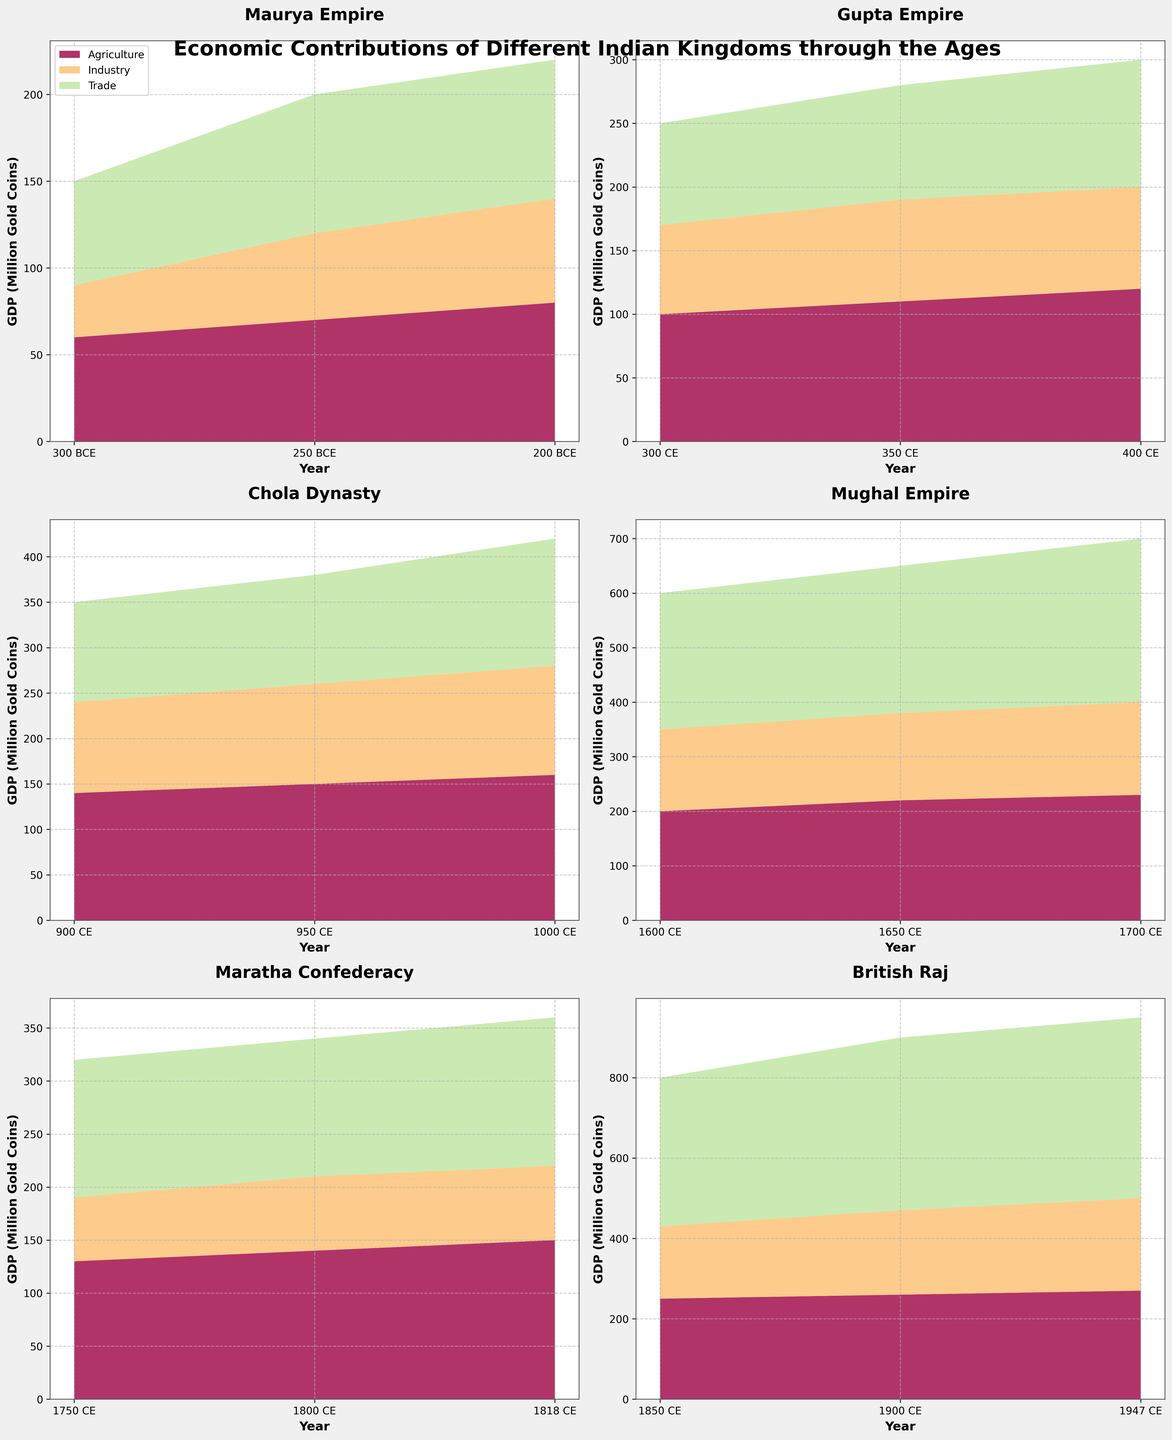Which kingdom has the highest GDP near the year 300 BCE? The plot shows the GDP for the Maurya Empire in 300 BCE. Comparing between periods, the Maurya Empire shows a GDP of 150 million gold coins.
Answer: Maurya Empire Over which years does the Gupta Empire show a consistent rise in GDP? Observing the Gupta Empire plot from 300 CE to 400 CE, each data point shows an increasing trend in GDP from 250 to 300 million gold coins.
Answer: 300 CE to 400 CE Which sector contributed the most to the GDP of the Mughal Empire in the year 1700 CE? Reviewing the plot for the Mughal Empire, the stacks for agriculture, industry, and trade, it is evident that trade, represented by the highest stack, contributes the most.
Answer: Trade In the plot for the Chola Dynasty, how does the GDP in 1000 CE compare to that in 900 CE? Looking at the Chola Dynasty subplot stacks, the GDP in 1000 CE is 420 million gold coins while in 900 CE it is 350 million gold coins, showing an increment of 70.
Answer: 70 million gold coins increase What is the range of GDP for the Maratha Confederacy according to the figure? Evaluating the Maratha Confederacy subplot, we see the lowest GDP is 320 million and the highest is 360 million gold coins. The range is calculated by subtracting the lower value from the higher value.
Answer: 40 million gold coins Among the kingdoms, which has the largest overall contribution from the industry sector over its time range? Comparing the data within the subplots, the industry sector's increase is maximum under the British Raj, reaching 230 million gold coins by 1947 CE.
Answer: British Raj During the period of the British Raj, which sector showed the smallest growth from 1850 CE to 1947 CE? The subplot for the British Raj indicates that agriculture grew from 250 to 270, showing the smallest increase compared to industry and trade.
Answer: Agriculture How does the economic contribution in agriculture by the Maurya Empire in 200 BCE compare to the British Raj in 1947 CE? Checking the relevant subplots for agriculture contributions, the Maurya Empire in 200 BCE contributed 80 million gold coins, while in 1947 CE the British Raj contributed 270 million gold coins. The difference is 190 million gold coins higher in 1947 CE.
Answer: 190 million gold coins higher In which year did the GDP of the Chola Dynasty first exceed 400 million gold coins? By examining the Chola Dynasty subplot, it can be seen that the GDP first exceeds 400 million gold coins in the year 1000 CE.
Answer: 1000 CE Which kingdom displayed the highest variance in trade contributions throughout its documented period? Looking across all subplots, the British Raj exhibits the greatest changes in trade contributions, rising from 370 to 450 million gold coins, indicating the highest variance.
Answer: British Raj 